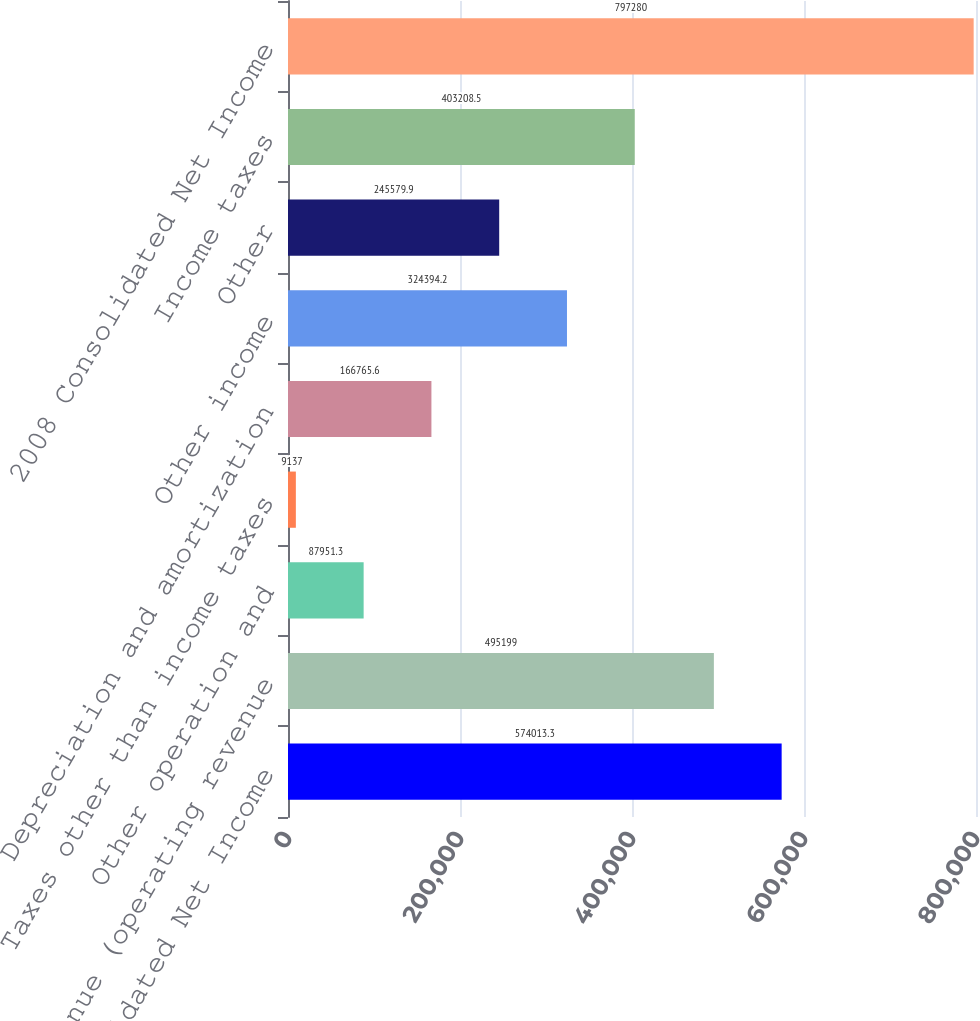Convert chart to OTSL. <chart><loc_0><loc_0><loc_500><loc_500><bar_chart><fcel>2007 Consolidated Net Income<fcel>Net revenue (operating revenue<fcel>Other operation and<fcel>Taxes other than income taxes<fcel>Depreciation and amortization<fcel>Other income<fcel>Other<fcel>Income taxes<fcel>2008 Consolidated Net Income<nl><fcel>574013<fcel>495199<fcel>87951.3<fcel>9137<fcel>166766<fcel>324394<fcel>245580<fcel>403208<fcel>797280<nl></chart> 